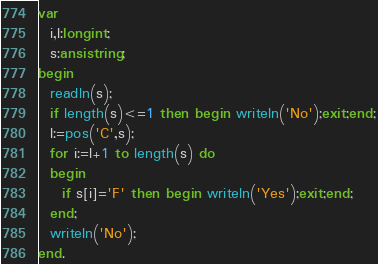<code> <loc_0><loc_0><loc_500><loc_500><_Pascal_>var
  i,l:longint;
  s:ansistring;
begin
  readln(s);
  if length(s)<=1 then begin writeln('No');exit;end;
  l:=pos('C',s);
  for i:=l+1 to length(s) do
  begin
    if s[i]='F' then begin writeln('Yes');exit;end;
  end;
  writeln('No');
end.</code> 